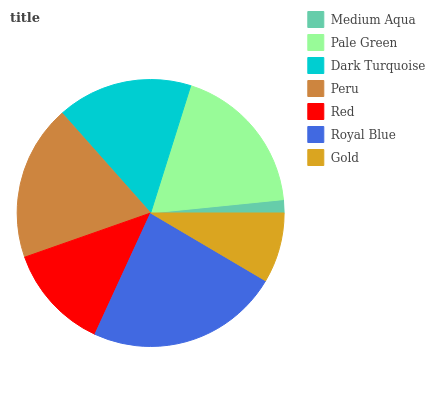Is Medium Aqua the minimum?
Answer yes or no. Yes. Is Royal Blue the maximum?
Answer yes or no. Yes. Is Pale Green the minimum?
Answer yes or no. No. Is Pale Green the maximum?
Answer yes or no. No. Is Pale Green greater than Medium Aqua?
Answer yes or no. Yes. Is Medium Aqua less than Pale Green?
Answer yes or no. Yes. Is Medium Aqua greater than Pale Green?
Answer yes or no. No. Is Pale Green less than Medium Aqua?
Answer yes or no. No. Is Dark Turquoise the high median?
Answer yes or no. Yes. Is Dark Turquoise the low median?
Answer yes or no. Yes. Is Medium Aqua the high median?
Answer yes or no. No. Is Gold the low median?
Answer yes or no. No. 